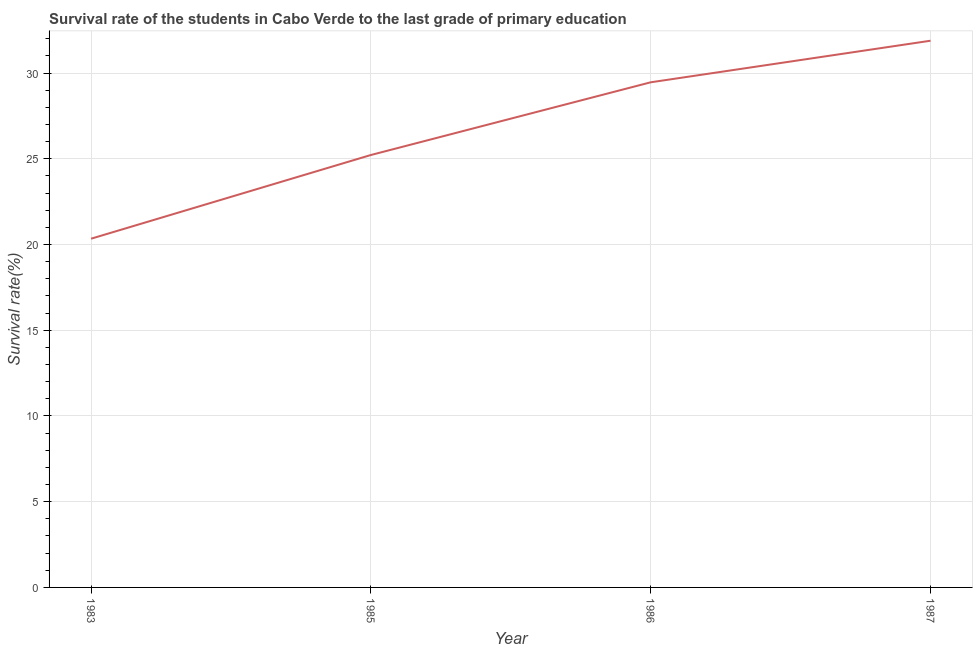What is the survival rate in primary education in 1987?
Your response must be concise. 31.89. Across all years, what is the maximum survival rate in primary education?
Offer a very short reply. 31.89. Across all years, what is the minimum survival rate in primary education?
Offer a terse response. 20.34. In which year was the survival rate in primary education maximum?
Provide a succinct answer. 1987. What is the sum of the survival rate in primary education?
Offer a very short reply. 106.91. What is the difference between the survival rate in primary education in 1983 and 1986?
Ensure brevity in your answer.  -9.12. What is the average survival rate in primary education per year?
Provide a short and direct response. 26.73. What is the median survival rate in primary education?
Offer a very short reply. 27.34. What is the ratio of the survival rate in primary education in 1983 to that in 1987?
Offer a terse response. 0.64. Is the survival rate in primary education in 1986 less than that in 1987?
Your response must be concise. Yes. Is the difference between the survival rate in primary education in 1983 and 1986 greater than the difference between any two years?
Offer a terse response. No. What is the difference between the highest and the second highest survival rate in primary education?
Your response must be concise. 2.42. What is the difference between the highest and the lowest survival rate in primary education?
Your answer should be compact. 11.55. Does the survival rate in primary education monotonically increase over the years?
Keep it short and to the point. Yes. How many lines are there?
Provide a succinct answer. 1. How many years are there in the graph?
Ensure brevity in your answer.  4. Does the graph contain grids?
Your answer should be compact. Yes. What is the title of the graph?
Your answer should be compact. Survival rate of the students in Cabo Verde to the last grade of primary education. What is the label or title of the Y-axis?
Your answer should be very brief. Survival rate(%). What is the Survival rate(%) of 1983?
Your answer should be compact. 20.34. What is the Survival rate(%) of 1985?
Your answer should be very brief. 25.22. What is the Survival rate(%) in 1986?
Provide a short and direct response. 29.46. What is the Survival rate(%) of 1987?
Your answer should be very brief. 31.89. What is the difference between the Survival rate(%) in 1983 and 1985?
Offer a very short reply. -4.88. What is the difference between the Survival rate(%) in 1983 and 1986?
Provide a short and direct response. -9.12. What is the difference between the Survival rate(%) in 1983 and 1987?
Provide a short and direct response. -11.55. What is the difference between the Survival rate(%) in 1985 and 1986?
Give a very brief answer. -4.24. What is the difference between the Survival rate(%) in 1985 and 1987?
Your response must be concise. -6.66. What is the difference between the Survival rate(%) in 1986 and 1987?
Your answer should be compact. -2.42. What is the ratio of the Survival rate(%) in 1983 to that in 1985?
Provide a short and direct response. 0.81. What is the ratio of the Survival rate(%) in 1983 to that in 1986?
Your response must be concise. 0.69. What is the ratio of the Survival rate(%) in 1983 to that in 1987?
Your response must be concise. 0.64. What is the ratio of the Survival rate(%) in 1985 to that in 1986?
Provide a short and direct response. 0.86. What is the ratio of the Survival rate(%) in 1985 to that in 1987?
Your answer should be compact. 0.79. What is the ratio of the Survival rate(%) in 1986 to that in 1987?
Offer a terse response. 0.92. 